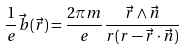Convert formula to latex. <formula><loc_0><loc_0><loc_500><loc_500>\frac { 1 } { e } \vec { b } ( \vec { r } ) = \frac { 2 \pi m } { e } \frac { \vec { r } \wedge \vec { n } } { r ( r - \vec { r } \cdot \vec { n } ) }</formula> 